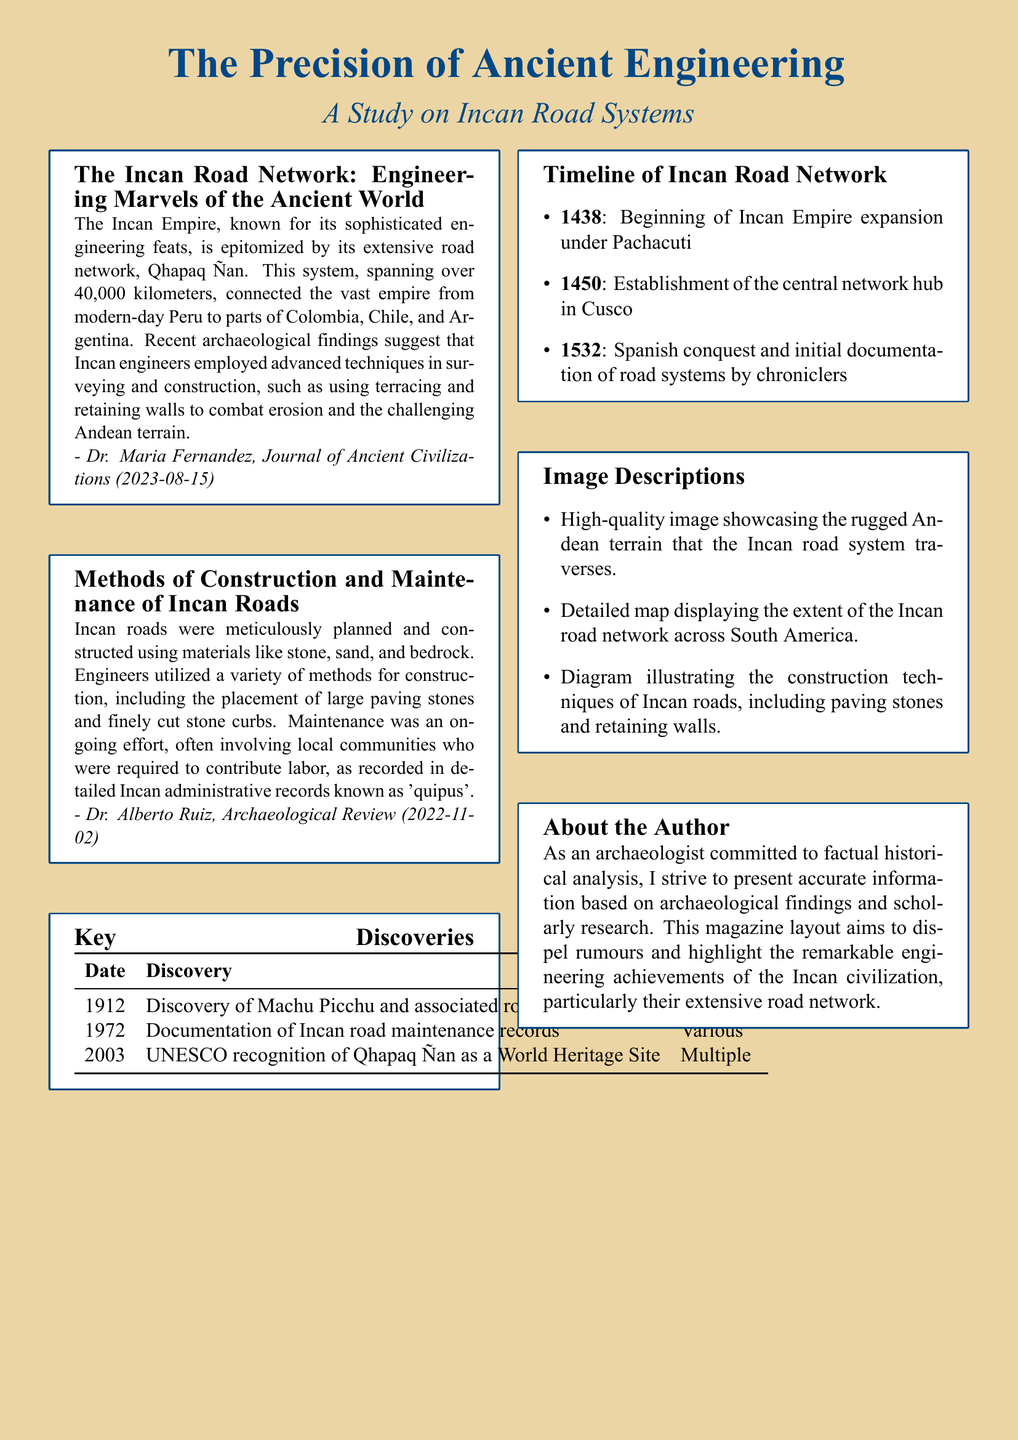What is the title of the magazine? The title can be found at the top of the document in a large font.
Answer: The Precision of Ancient Engineering Who wrote the article about Incan road systems? The author's name is stated in the "About the Author" section.
Answer: Dr. Maria Fernandez When was Machu Picchu discovered? The date is listed in the "Key Discoveries" table.
Answer: 1912 What was established in 1450? This information is detailed in the timeline of the Incan road network.
Answer: The central network hub in Cusco How long is the Incan road network? The length is provided in the introductory text about the Incan road network.
Answer: Over 40,000 kilometers Which civilization is the focus of this document? The civilization is mentioned multiple times throughout the document.
Answer: Incan What type of records were used for documenting road maintenance? The records are specifically named in the article discussing construction and maintenance.
Answer: Quipus What is illustrated in the diagrams described in the document? The document mentions various diagrams that provide visual information.
Answer: Construction techniques of Incan roads What year marks the Spanish conquest of the Incan Empire? This significant historical date is noted in the timeline.
Answer: 1532 